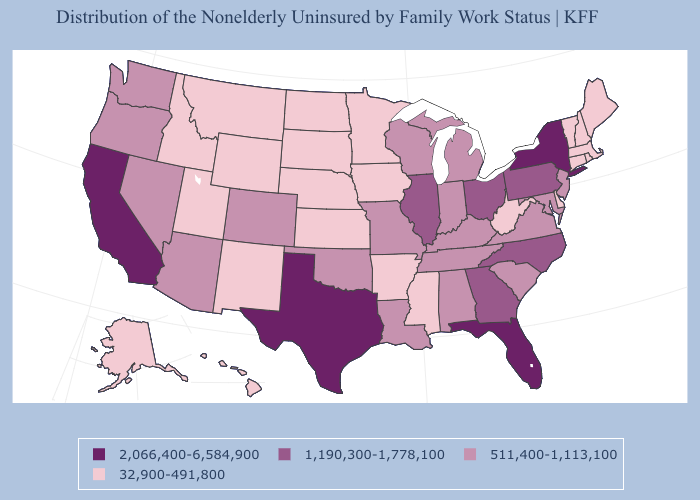What is the lowest value in the USA?
Concise answer only. 32,900-491,800. How many symbols are there in the legend?
Answer briefly. 4. Does Idaho have the same value as Alaska?
Keep it brief. Yes. What is the highest value in the USA?
Give a very brief answer. 2,066,400-6,584,900. Among the states that border Wyoming , does South Dakota have the lowest value?
Be succinct. Yes. What is the lowest value in the MidWest?
Keep it brief. 32,900-491,800. Name the states that have a value in the range 2,066,400-6,584,900?
Concise answer only. California, Florida, New York, Texas. What is the value of Michigan?
Answer briefly. 511,400-1,113,100. What is the value of Montana?
Answer briefly. 32,900-491,800. What is the highest value in the USA?
Be succinct. 2,066,400-6,584,900. How many symbols are there in the legend?
Short answer required. 4. What is the highest value in states that border Indiana?
Write a very short answer. 1,190,300-1,778,100. Among the states that border North Carolina , does Georgia have the highest value?
Be succinct. Yes. Does Louisiana have the highest value in the South?
Short answer required. No. What is the value of Indiana?
Answer briefly. 511,400-1,113,100. 